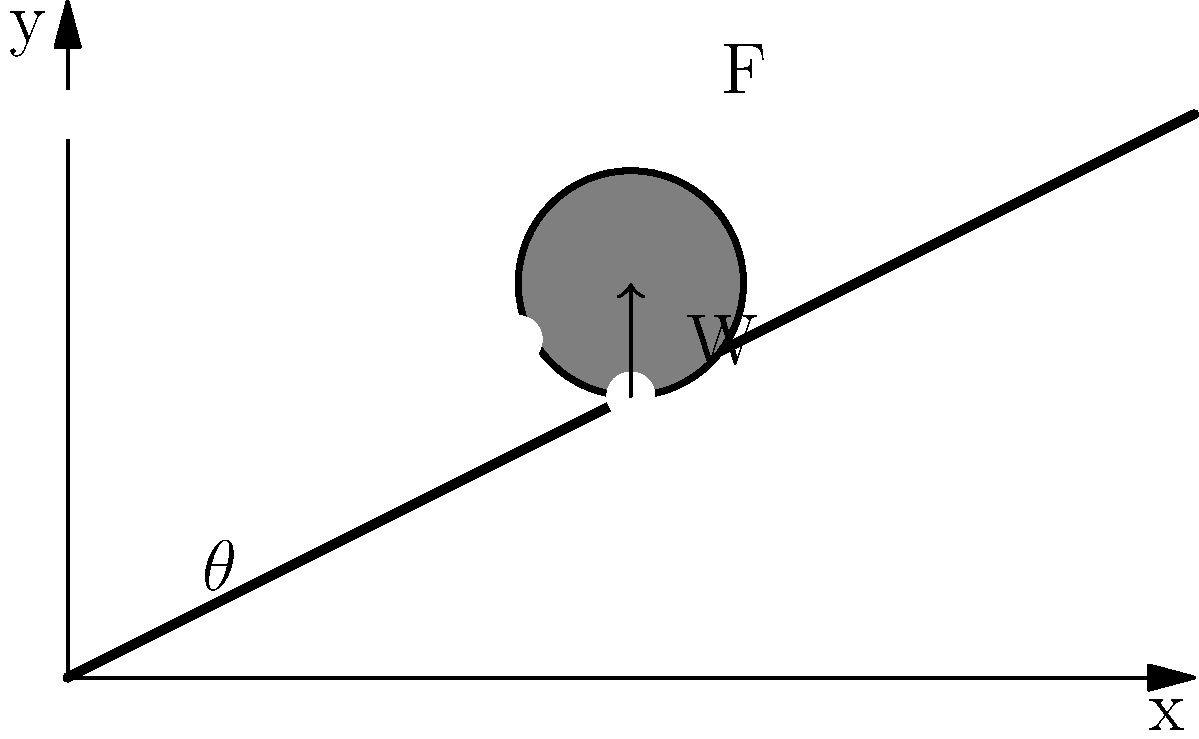A locomotive is traveling up an inclined track at a constant speed during a heavy snowstorm. The track has an inclination angle $\theta = 10°$, and the locomotive's mass is $m = 150,000$ kg. The coefficient of rolling resistance under normal conditions is $\mu_r = 0.002$, but due to snow, there's an additional resistance force of $F_s = 20,000$ N. Calculate the power required for the locomotive to maintain a constant speed of $v = 72$ km/h (20 m/s) up the incline. To solve this problem, we'll follow these steps:

1) First, calculate the component of the weight parallel to the incline:
   $F_w = mg \sin(\theta) = 150,000 \cdot 9.8 \cdot \sin(10°) = 255,179$ N

2) Calculate the normal force:
   $N = mg \cos(\theta) = 150,000 \cdot 9.8 \cdot \cos(10°) = 1,448,021$ N

3) Calculate the rolling resistance force:
   $F_r = \mu_r N = 0.002 \cdot 1,448,021 = 2,896$ N

4) Sum up all the resistive forces:
   $F_{total} = F_w + F_r + F_s = 255,179 + 2,896 + 20,000 = 278,075$ N

5) The power required is the product of the total force and velocity:
   $P = F_{total} \cdot v = 278,075 \cdot 20 = 5,561,500$ W or 5,561.5 kW

Therefore, the locomotive requires 5,561.5 kW of power to maintain its speed under these conditions.
Answer: 5,561.5 kW 